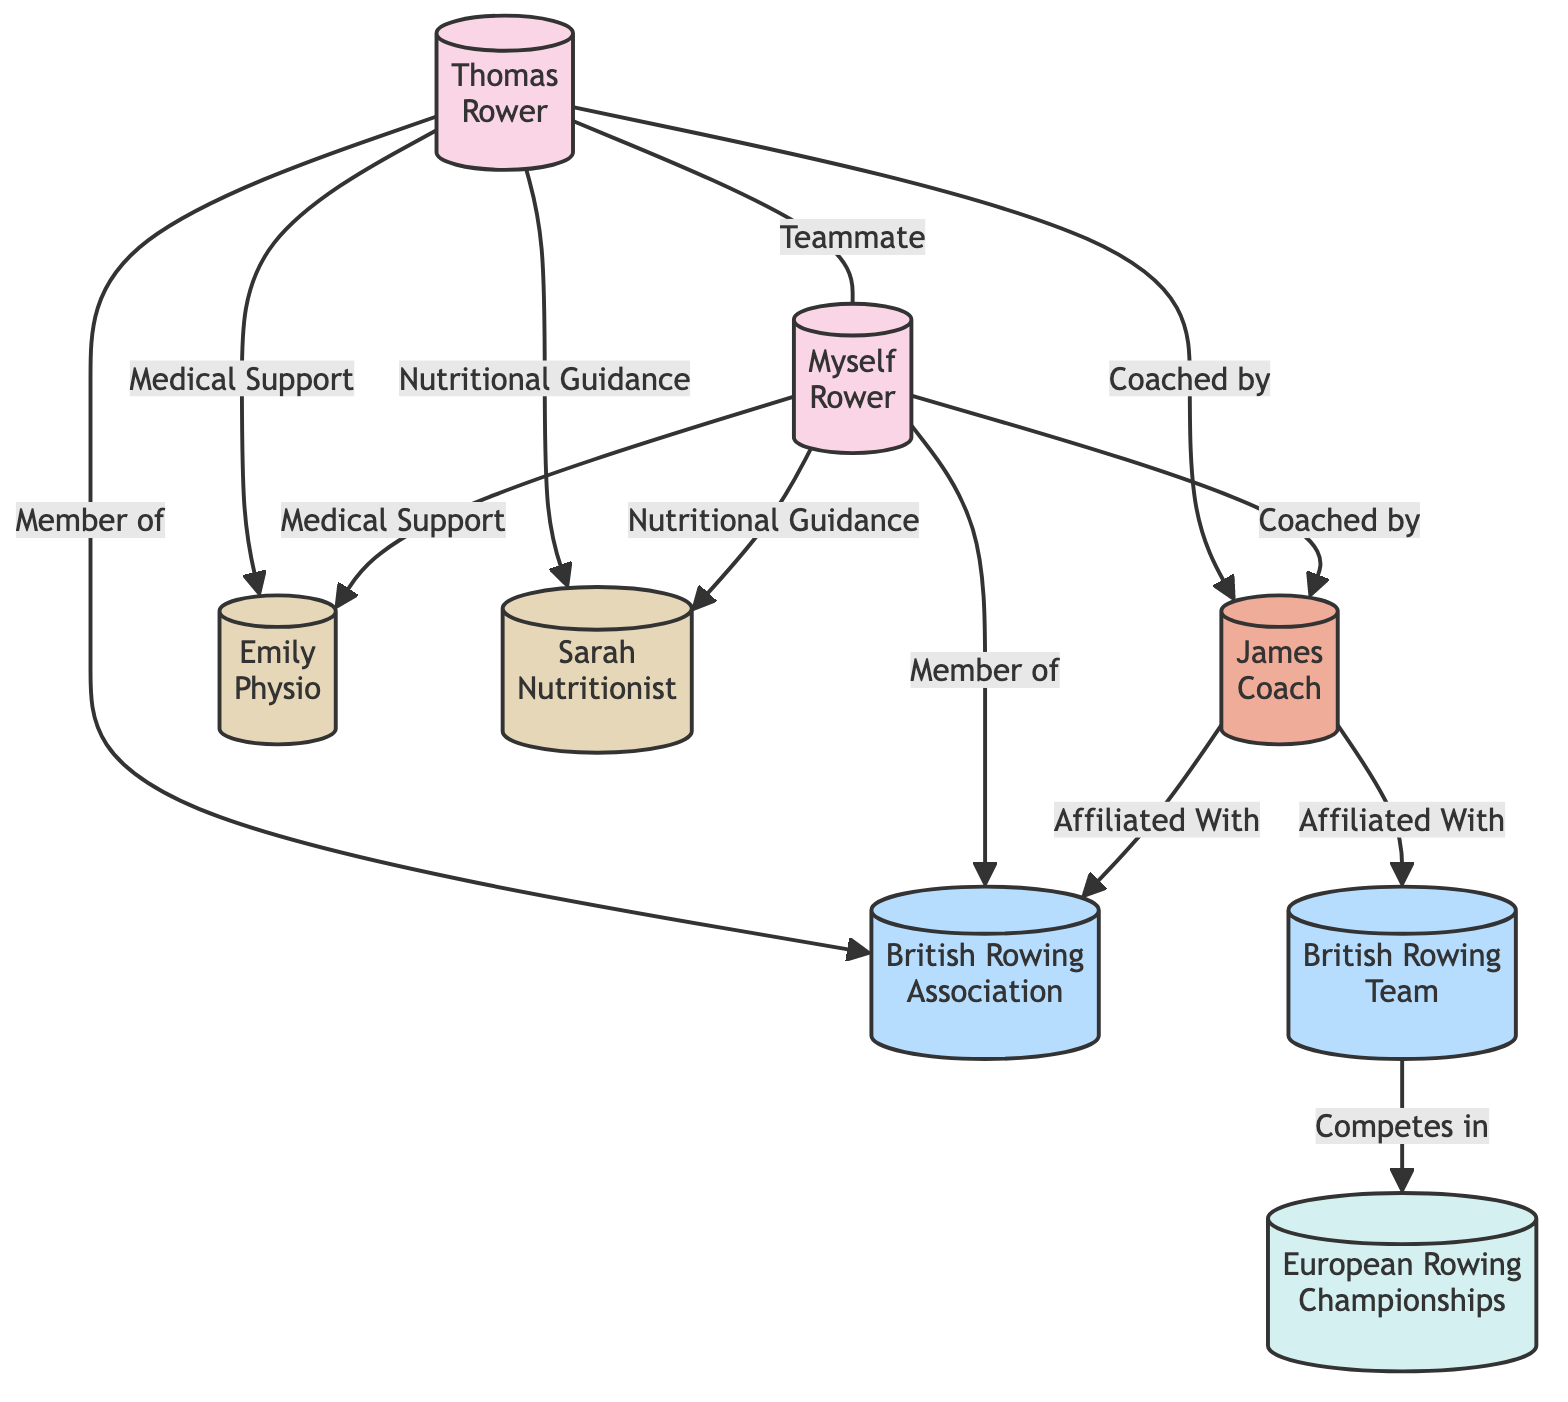What is the role of the person with ID 1? The person with ID 1 is named Thomas and is identified as a Rower.
Answer: Rower Who is Thomas's coach? The diagram shows that Thomas has a relationship called "Coached by" with James, who has the role of Coach.
Answer: James How many nodes are present in the diagram? The diagram has a total of 8 nodes representing individuals, organizations, and events.
Answer: 8 What type of support is provided to both Thomas and Myself? Both Thomas and Myself receive "Medical Support" from Emily, the Physiotherapist.
Answer: Medical Support Which organization is affiliated with James? James is "Affiliated With" the British Rowing Association as indicated in the relationship present in the diagram.
Answer: British Rowing Association What is the relationship type between Thomas and Myself? The relationship between Thomas and Myself is identified as "Teammate," indicating that they compete together.
Answer: Teammate In what event does the British Rowing Team compete? According to the diagram, the British Rowing Team participates in the European Rowing Championships as described in their relationship.
Answer: European Rowing Championships Who provides nutritional guidance to the athletes? The nutritional guidance is provided by Sarah, the Nutritionist, as indicated by the support relationships in the diagram.
Answer: Sarah What is the frequency of the European Rowing Championships? The diagram states that the European Rowing Championships occur on an annual basis.
Answer: Annual 